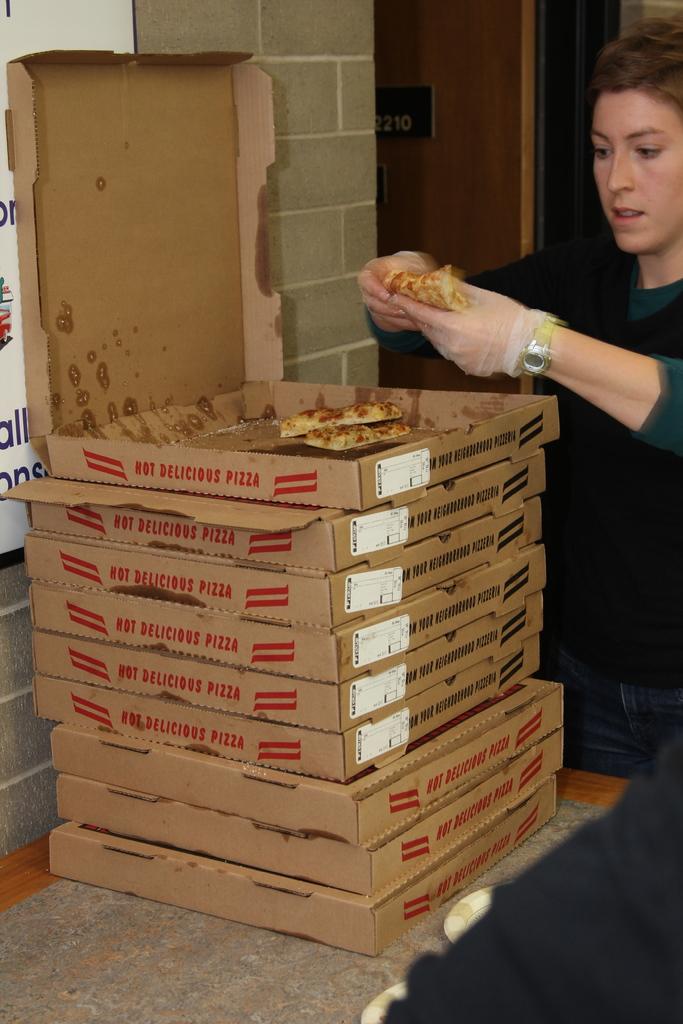How many boxes of pizza are there?
Keep it short and to the point. 9. 